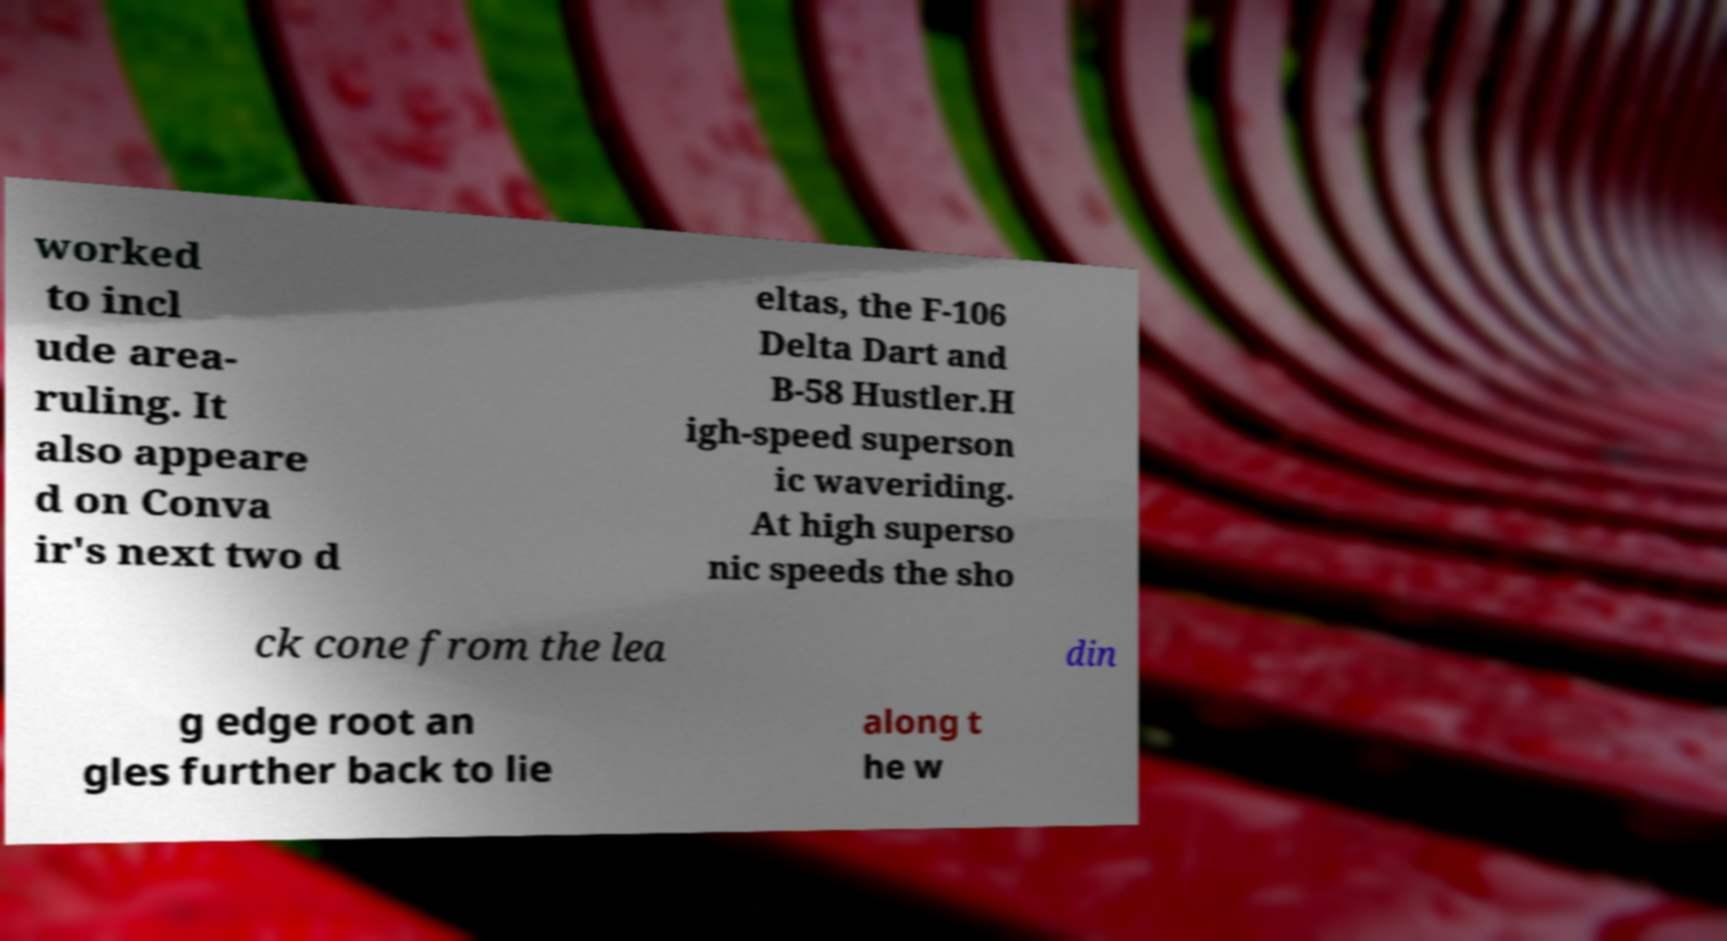Could you extract and type out the text from this image? worked to incl ude area- ruling. It also appeare d on Conva ir's next two d eltas, the F-106 Delta Dart and B-58 Hustler.H igh-speed superson ic waveriding. At high superso nic speeds the sho ck cone from the lea din g edge root an gles further back to lie along t he w 